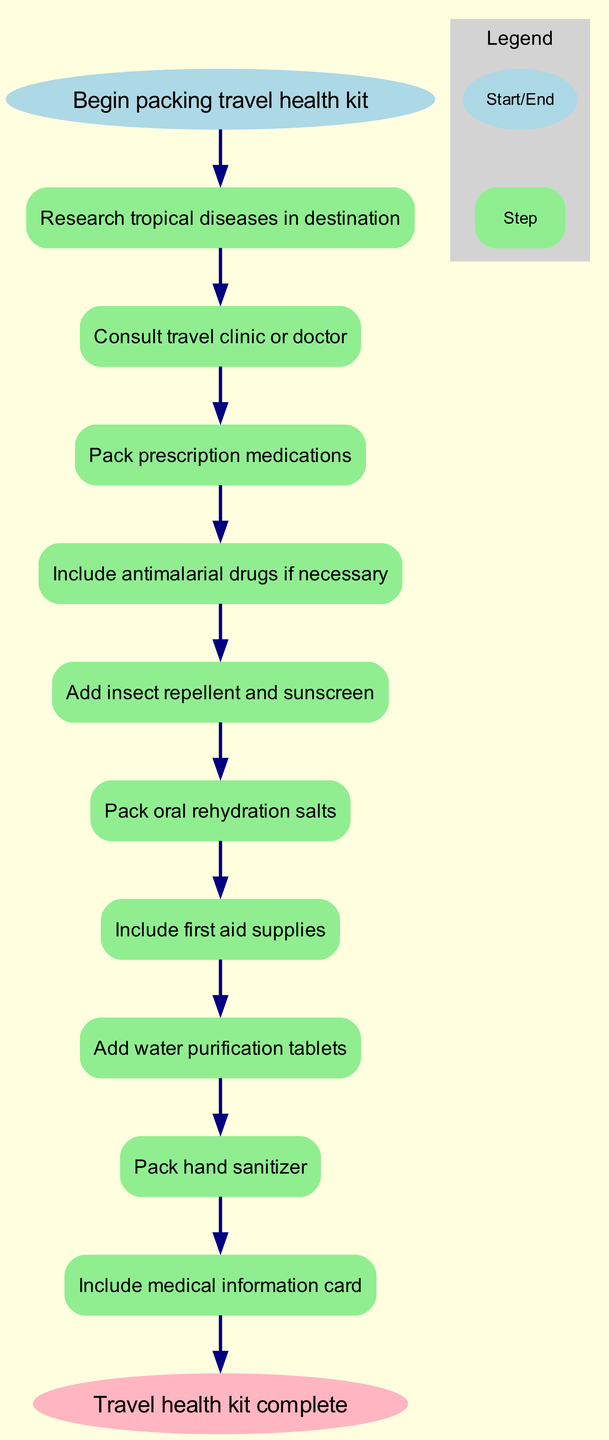What is the first step in packing the travel health kit? The diagram indicates the first step in the process is to "Research tropical diseases in destination," which is the first node after the start node.
Answer: Research tropical diseases in destination How many steps are included in the flowchart? By counting the nodes labeled with the steps, there are a total of 10 steps outlined in the diagram before reaching the end node.
Answer: 10 What is the last step before completing the travel health kit? The last step indicated in the flowchart, before reaching the end, is to "Include medical information card," which is the final action recommended.
Answer: Include medical information card What type of products are advised to be packed after insect repellent? After insect repellent, the next item to be packed as per the flowchart is "oral rehydration salts." This is directly indicated in the sequence of steps.
Answer: Oral rehydration salts Which step involves consulting a professional about travel health? The step where a professional is consulted is "Consult travel clinic or doctor." This step is the second step in the flowchart, directly following the research step.
Answer: Consult travel clinic or doctor How many supplies are packed before including the medical information card? The steps leading up to the medical information card include 9 other entries, counting all preceding steps in the diagram, which leads to the conclusion that there are 9 supplies packed before it.
Answer: 9 What type of step is "Add water purification tablets"? This step falls under the category of first aid and safety supplies, indicating a critical action for health and hygiene when traveling to tropical regions.
Answer: First aid and safety supplies From which step does "Pack hand sanitizer" follow? "Pack hand sanitizer" follows after "Add water purification tablets," which is apparent as it is the next node in the sequence from the flowchart.
Answer: Add water purification tablets 